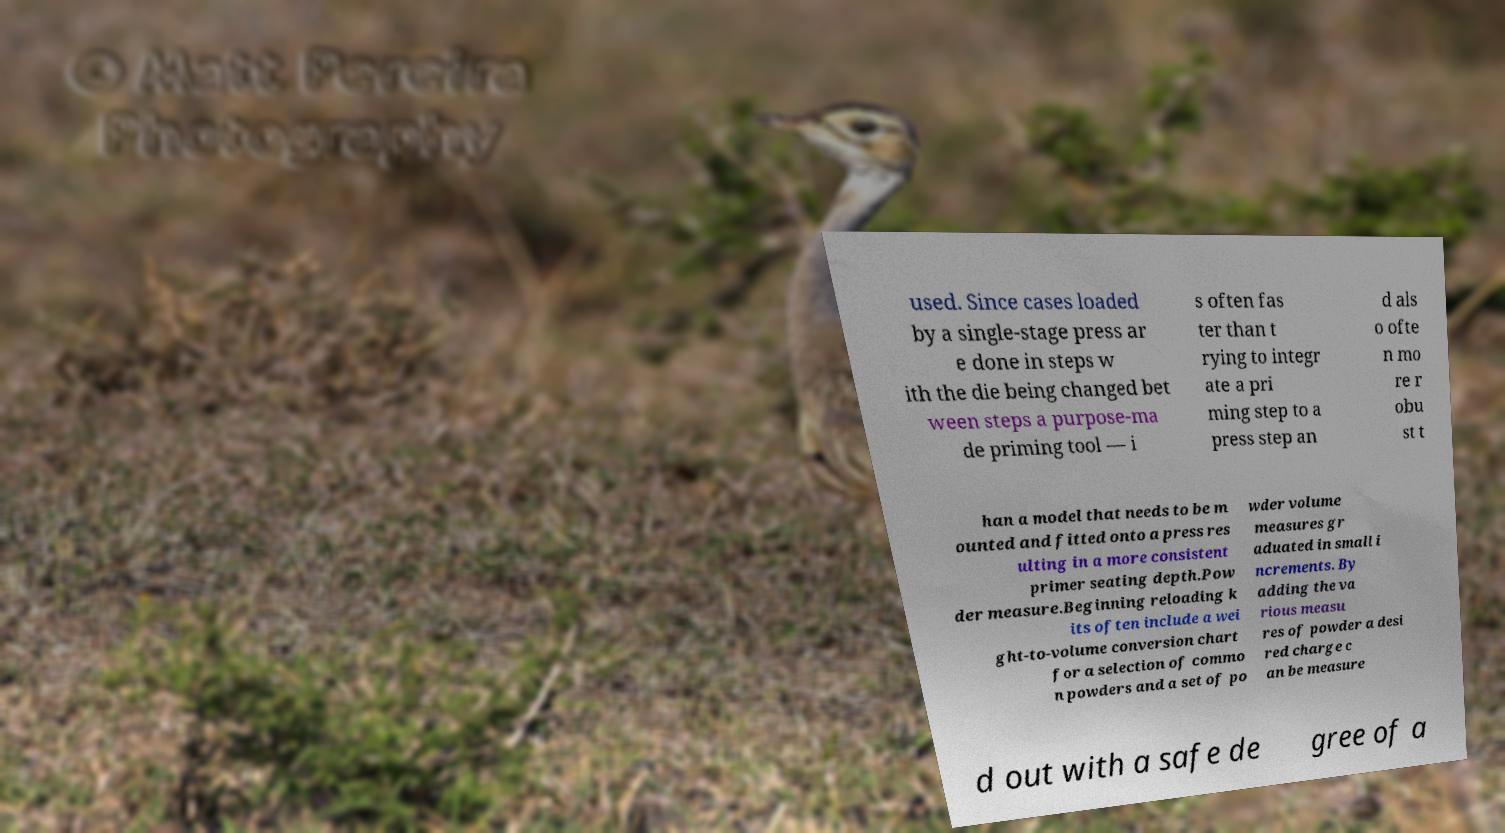I need the written content from this picture converted into text. Can you do that? used. Since cases loaded by a single-stage press ar e done in steps w ith the die being changed bet ween steps a purpose-ma de priming tool — i s often fas ter than t rying to integr ate a pri ming step to a press step an d als o ofte n mo re r obu st t han a model that needs to be m ounted and fitted onto a press res ulting in a more consistent primer seating depth.Pow der measure.Beginning reloading k its often include a wei ght-to-volume conversion chart for a selection of commo n powders and a set of po wder volume measures gr aduated in small i ncrements. By adding the va rious measu res of powder a desi red charge c an be measure d out with a safe de gree of a 